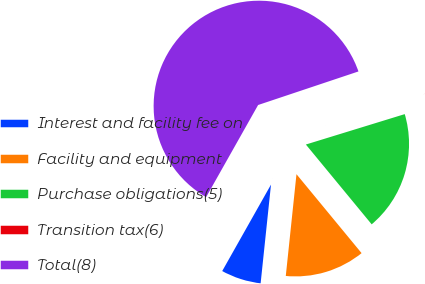Convert chart. <chart><loc_0><loc_0><loc_500><loc_500><pie_chart><fcel>Interest and facility fee on<fcel>Facility and equipment<fcel>Purchase obligations(5)<fcel>Transition tax(6)<fcel>Total(8)<nl><fcel>6.51%<fcel>12.64%<fcel>18.77%<fcel>0.39%<fcel>61.68%<nl></chart> 